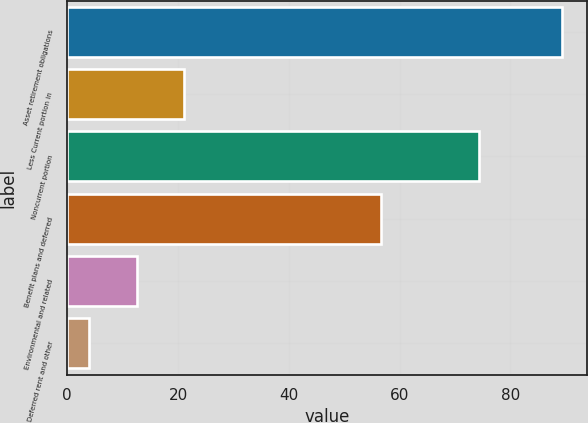<chart> <loc_0><loc_0><loc_500><loc_500><bar_chart><fcel>Asset retirement obligations<fcel>Less Current portion in<fcel>Noncurrent portion<fcel>Benefit plans and deferred<fcel>Environmental and related<fcel>Deferred rent and other<nl><fcel>89.4<fcel>21.08<fcel>74.4<fcel>56.7<fcel>12.54<fcel>4<nl></chart> 